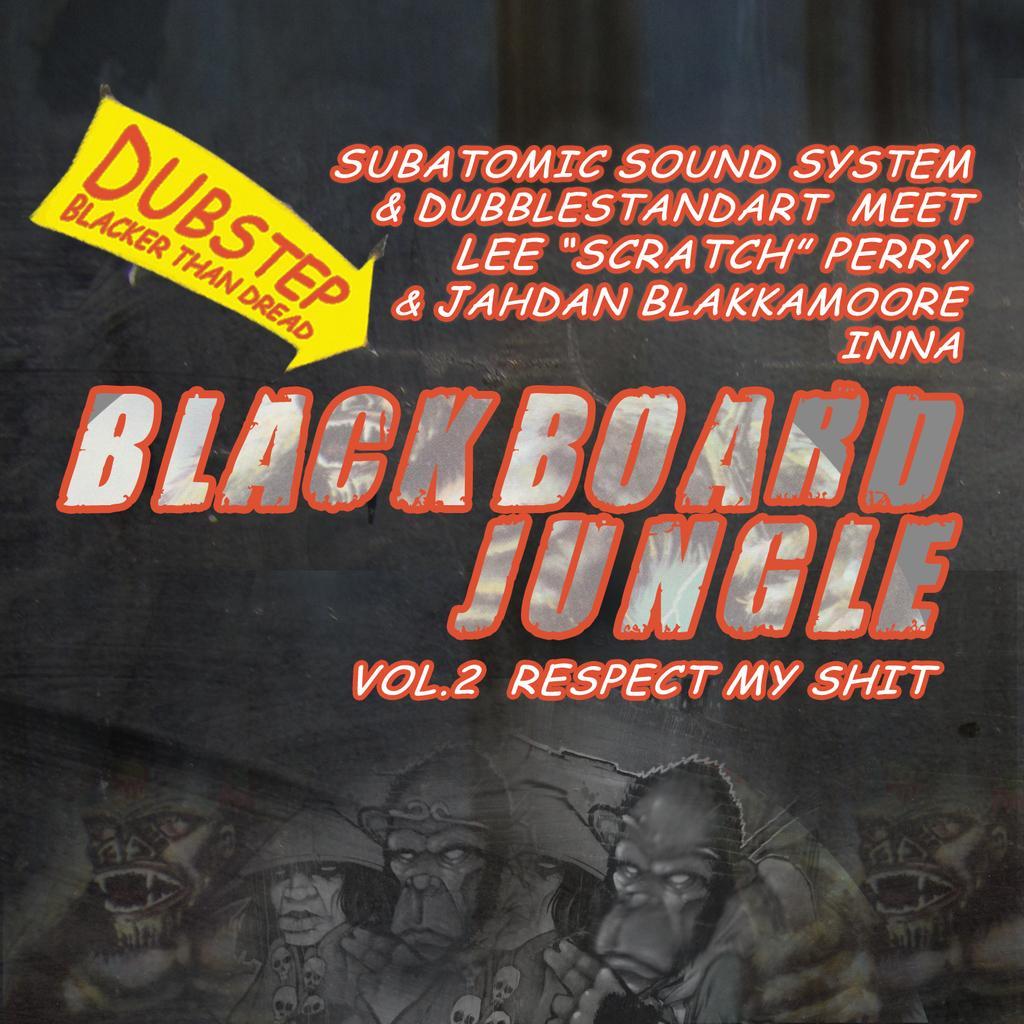Can you describe this image briefly? We can see poster,on this poster we can see alliance and text. 